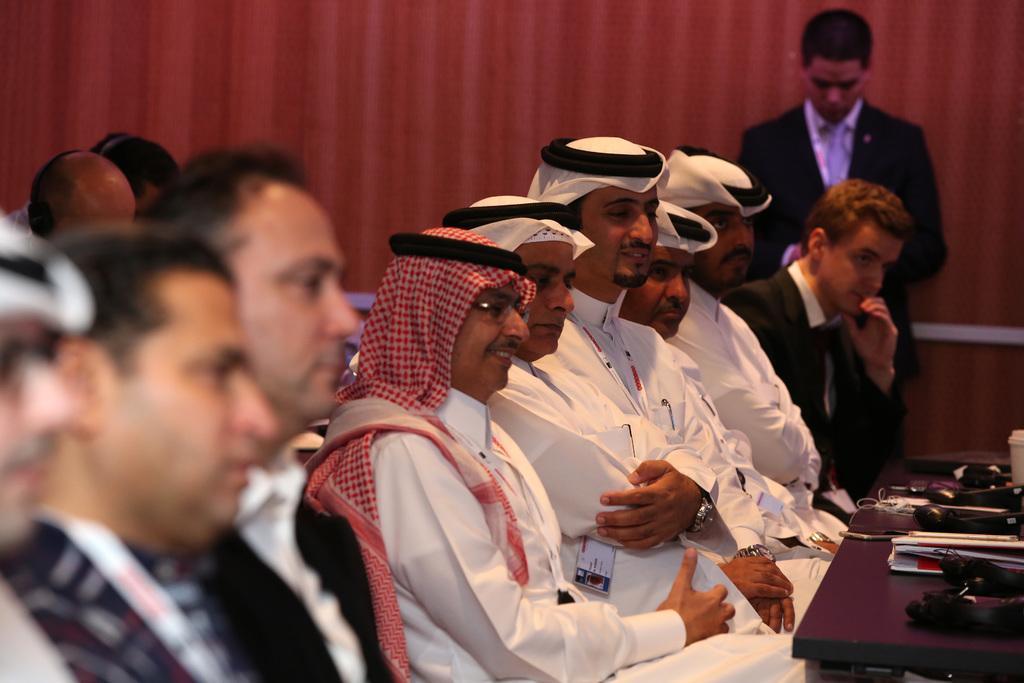In one or two sentences, can you explain what this image depicts? The image consists of many arab man and other men sat in front of table,this seems to be a meeting room. 